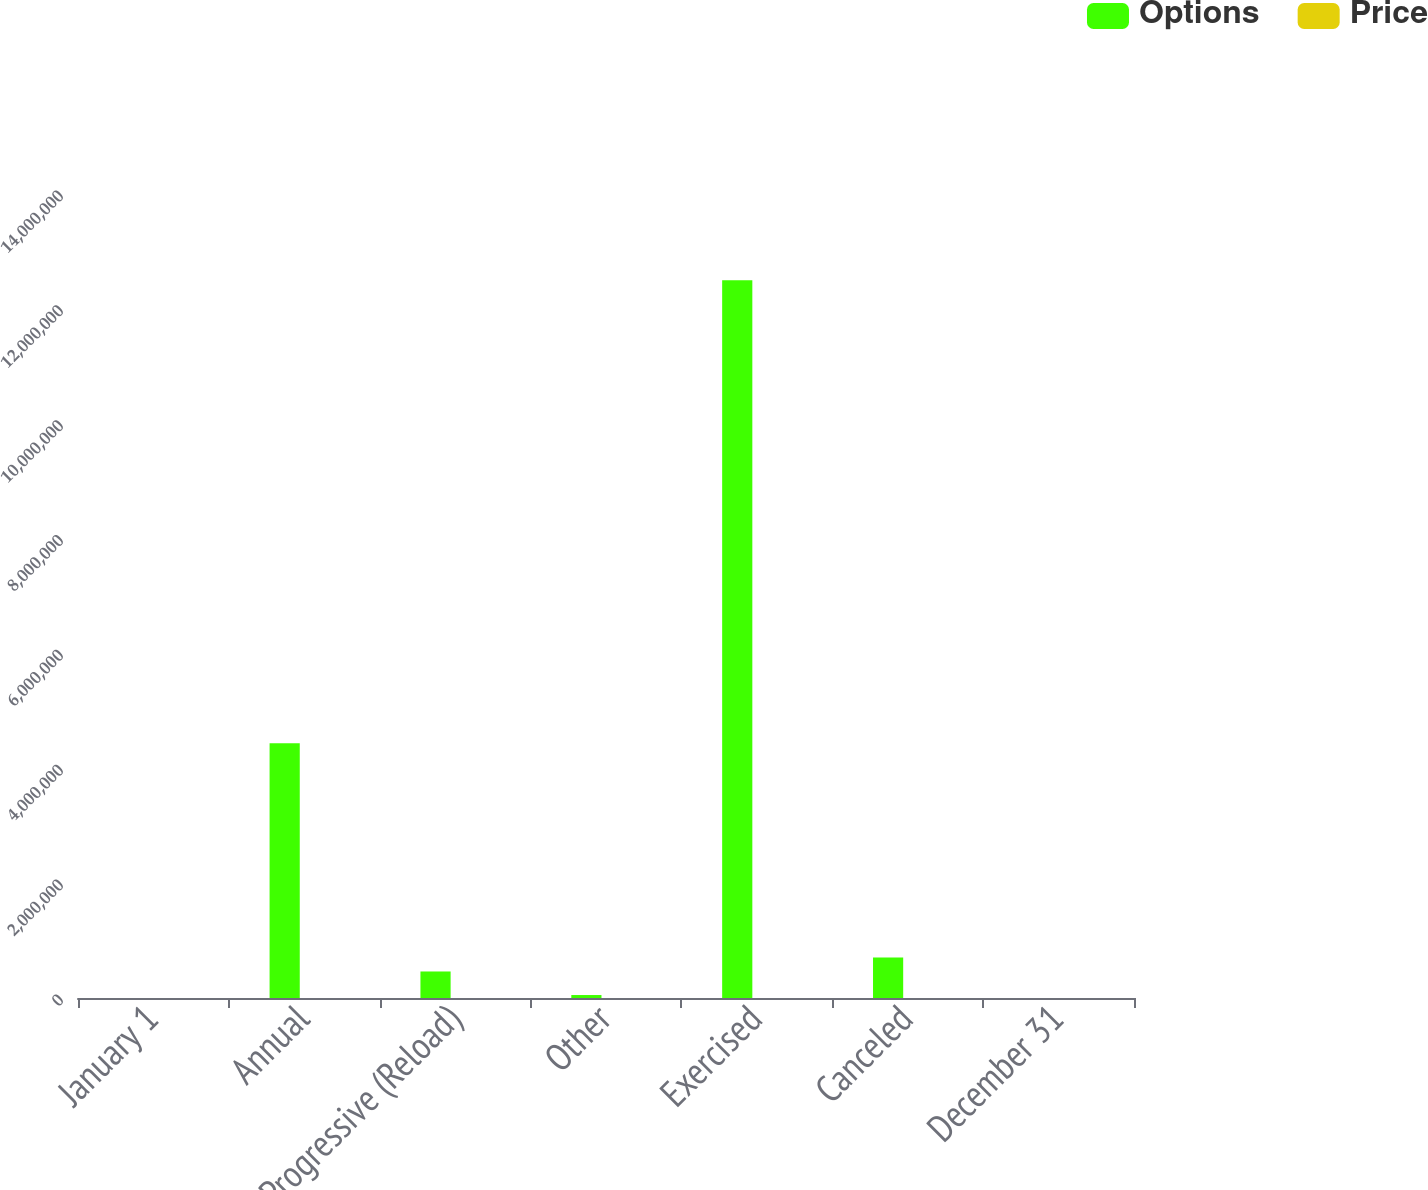Convert chart. <chart><loc_0><loc_0><loc_500><loc_500><stacked_bar_chart><ecel><fcel>January 1<fcel>Annual<fcel>Progressive (Reload)<fcel>Other<fcel>Exercised<fcel>Canceled<fcel>December 31<nl><fcel>Options<fcel>85.965<fcel>4.43458e+06<fcel>461815<fcel>51730<fcel>1.24981e+07<fcel>704929<fcel>85.965<nl><fcel>Price<fcel>67.41<fcel>84.81<fcel>87.12<fcel>82.93<fcel>55.34<fcel>77.36<fcel>70.5<nl></chart> 